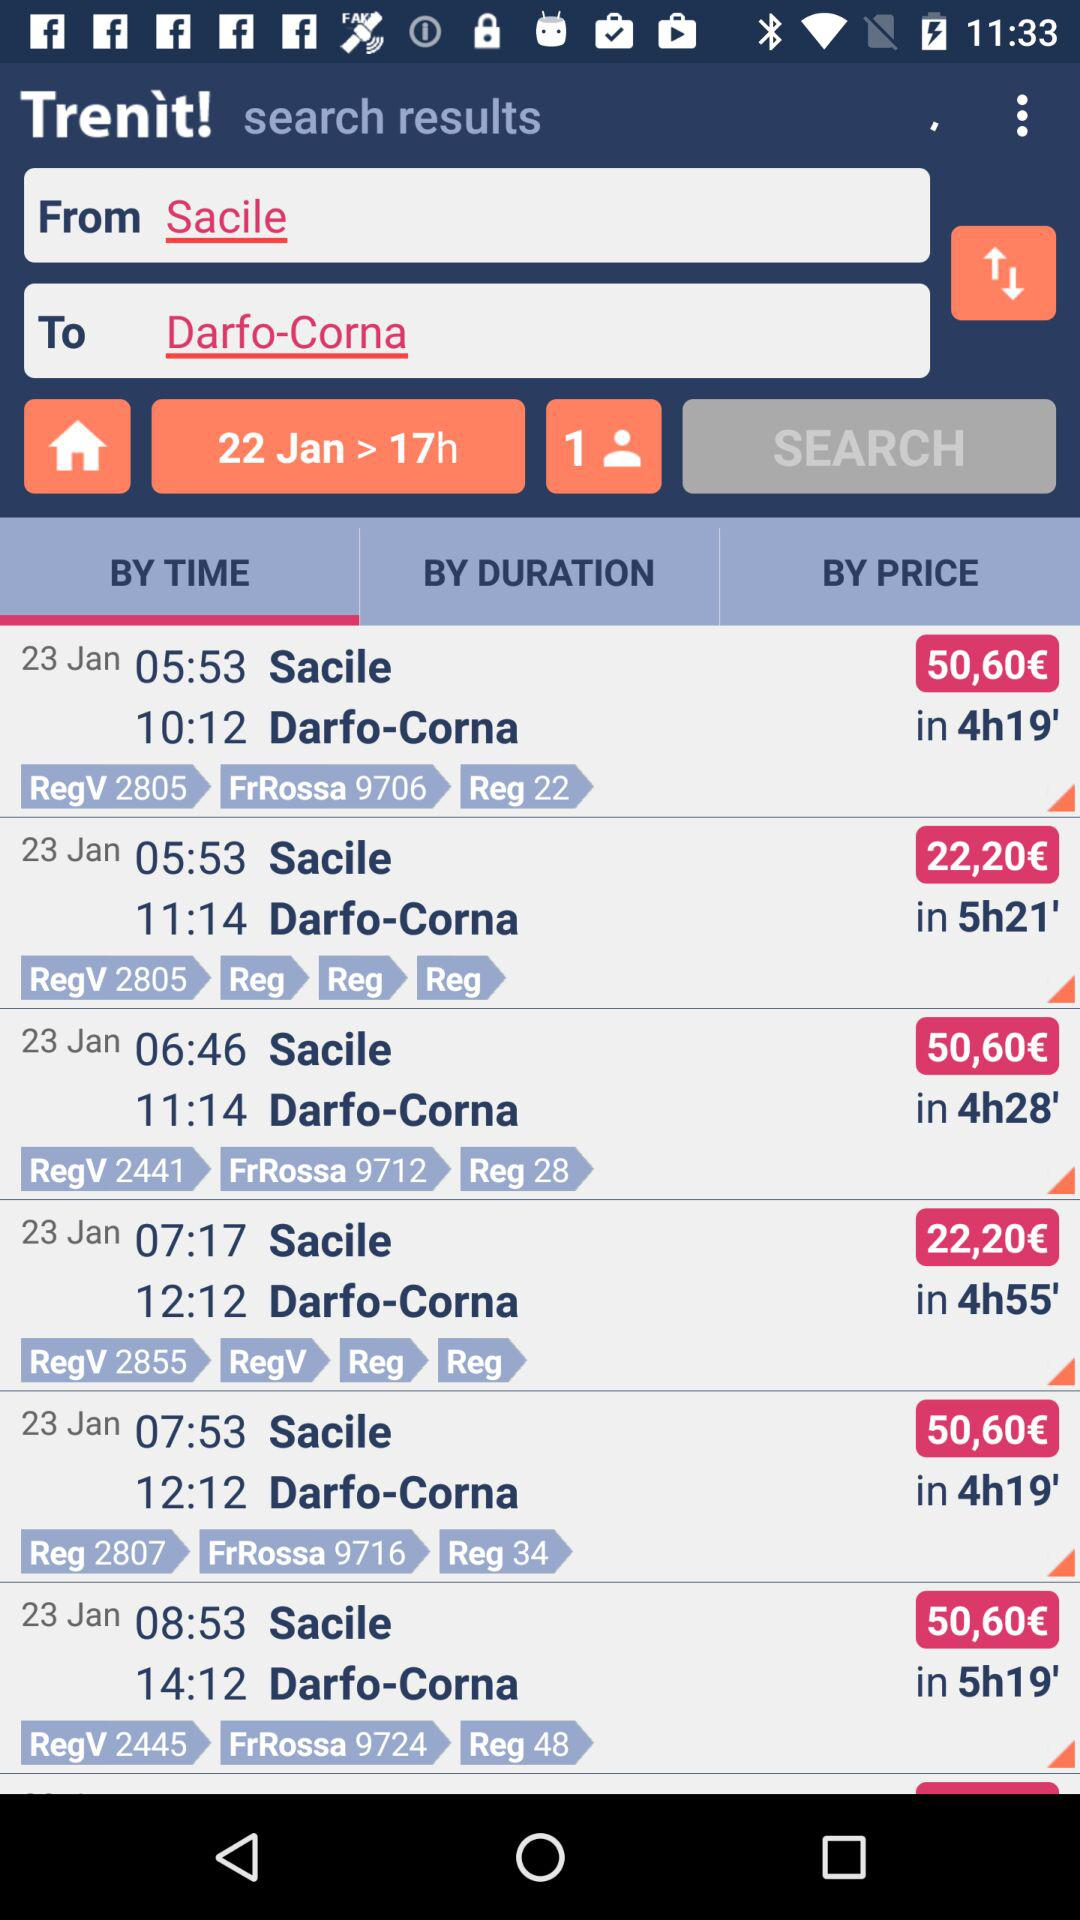How many individuals do we need to find seats for? You need to find seat for 1 individual. 